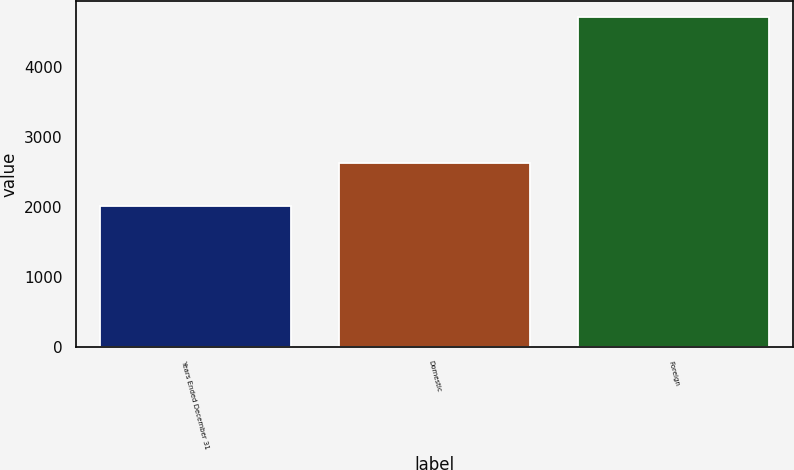Convert chart to OTSL. <chart><loc_0><loc_0><loc_500><loc_500><bar_chart><fcel>Years Ended December 31<fcel>Domestic<fcel>Foreign<nl><fcel>2011<fcel>2626<fcel>4708<nl></chart> 